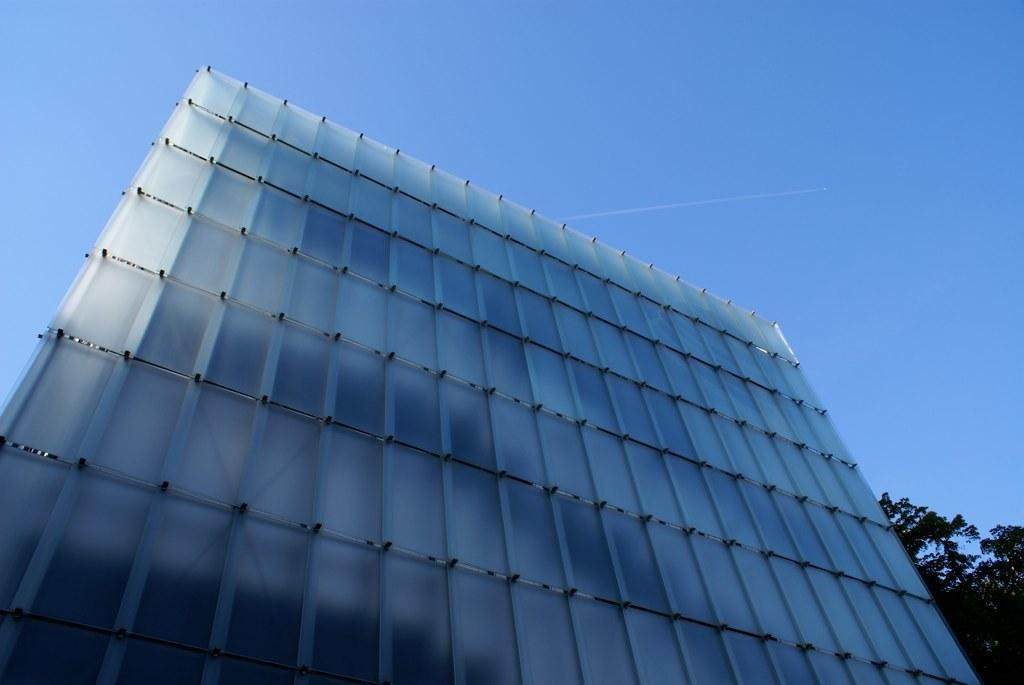What is the main structure in the image? There is a huge building in the image. What is covering the building? The building is covered with sheets. What type of natural elements can be seen in the image? There are trees in the image. What is visible in the background of the image? The sky is visible in the background of the image. Can you see a person driving a truck on the ground in the image? There is no person or truck present on the ground in the image. 